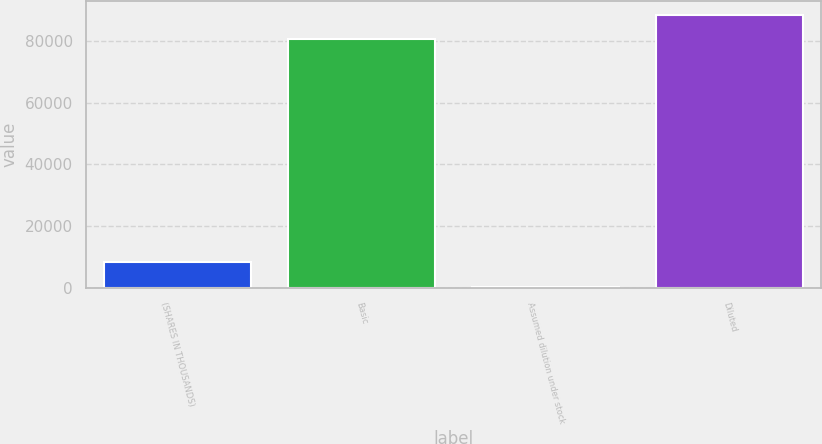<chart> <loc_0><loc_0><loc_500><loc_500><bar_chart><fcel>(SHARES IN THOUSANDS)<fcel>Basic<fcel>Assumed dilution under stock<fcel>Diluted<nl><fcel>8486.9<fcel>80449<fcel>442<fcel>88493.9<nl></chart> 